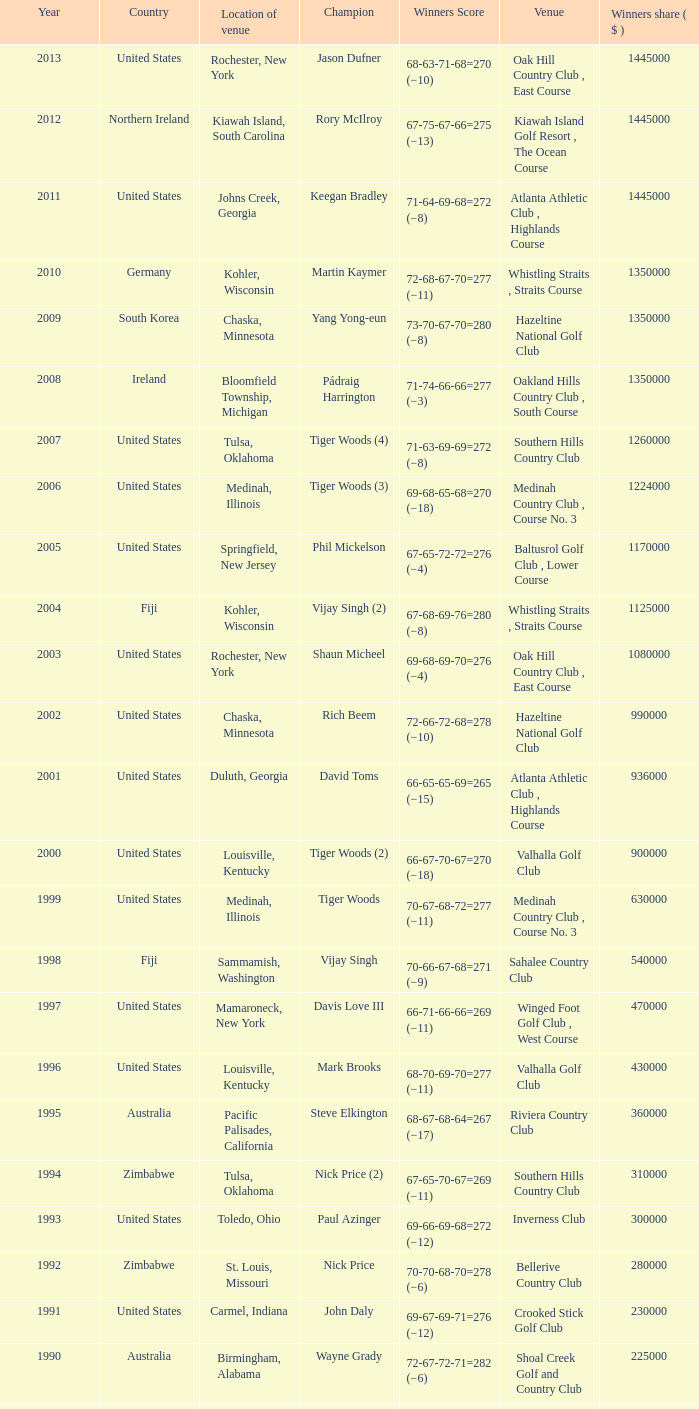Where is the Bellerive Country Club venue located? St. Louis, Missouri. 